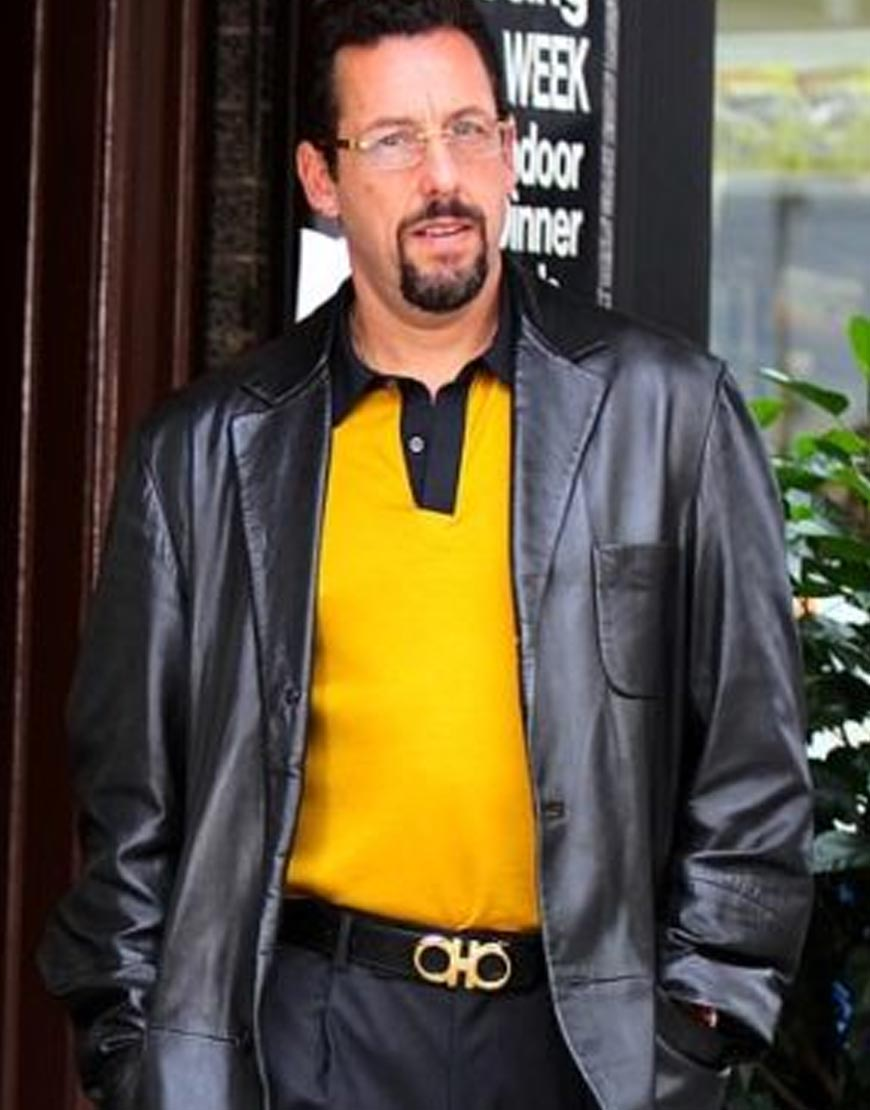Describe a realistic short scenario involving the man with a focus on his current surroundings. The man casually walks along a bustling city street, pausing momentarily in front of a chic restaurant. He checks his phone for messages, indicating he might be waiting for someone. The soft chatter of people dining al fresco and the occasional passing car provide a lively backdrop. He straightens his jacket, taking a deep breath, readying himself for what might be an important meeting or reunion inside. 